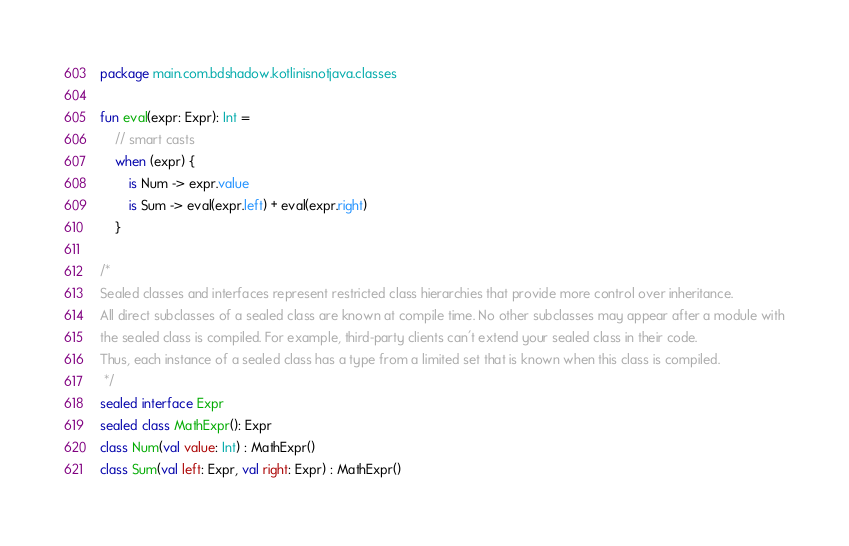<code> <loc_0><loc_0><loc_500><loc_500><_Kotlin_>package main.com.bdshadow.kotlinisnotjava.classes

fun eval(expr: Expr): Int =
    // smart casts
    when (expr) {
        is Num -> expr.value
        is Sum -> eval(expr.left) + eval(expr.right)
    }

/*
Sealed classes and interfaces represent restricted class hierarchies that provide more control over inheritance.
All direct subclasses of a sealed class are known at compile time. No other subclasses may appear after a module with
the sealed class is compiled. For example, third-party clients can't extend your sealed class in their code.
Thus, each instance of a sealed class has a type from a limited set that is known when this class is compiled.
 */
sealed interface Expr
sealed class MathExpr(): Expr
class Num(val value: Int) : MathExpr()
class Sum(val left: Expr, val right: Expr) : MathExpr()</code> 